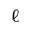Convert formula to latex. <formula><loc_0><loc_0><loc_500><loc_500>\ell</formula> 